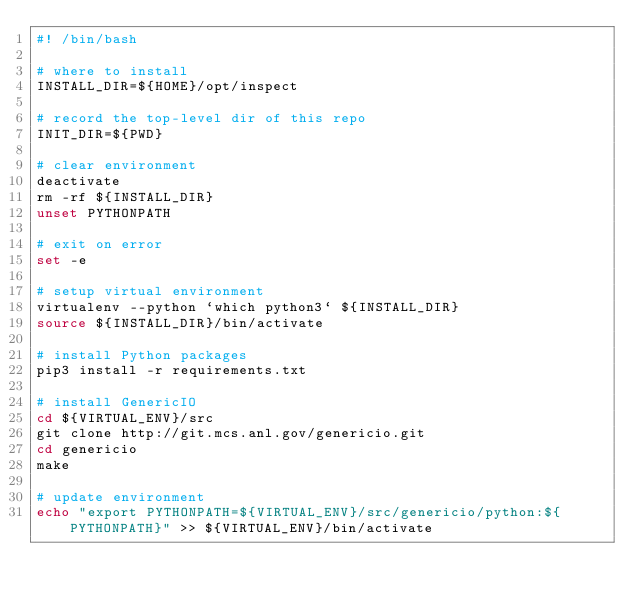<code> <loc_0><loc_0><loc_500><loc_500><_Bash_>#! /bin/bash

# where to install
INSTALL_DIR=${HOME}/opt/inspect

# record the top-level dir of this repo
INIT_DIR=${PWD}

# clear environment
deactivate
rm -rf ${INSTALL_DIR}
unset PYTHONPATH

# exit on error
set -e

# setup virtual environment
virtualenv --python `which python3` ${INSTALL_DIR}
source ${INSTALL_DIR}/bin/activate

# install Python packages
pip3 install -r requirements.txt

# install GenericIO
cd ${VIRTUAL_ENV}/src
git clone http://git.mcs.anl.gov/genericio.git
cd genericio
make

# update environment
echo "export PYTHONPATH=${VIRTUAL_ENV}/src/genericio/python:${PYTHONPATH}" >> ${VIRTUAL_ENV}/bin/activate
</code> 